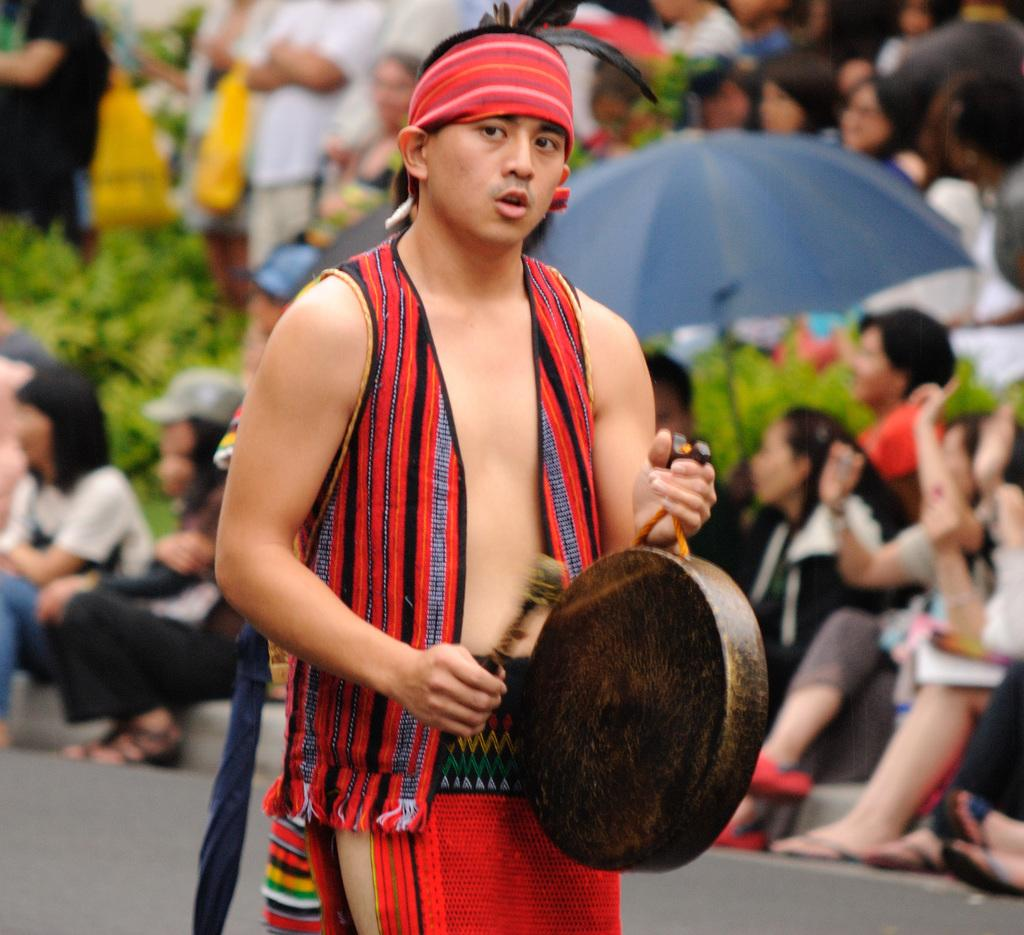What is the man in the image doing? The man is playing a drum. Are there any other people in the image besides the man? Yes, there are people behind the man. What type of vegetation can be seen in the image? There are plants in the image. What object is present to provide shade or protection from the elements? There is an umbrella in the image. Can you describe the process of the frog jumping in the image? There is no frog present in the image, so it is not possible to describe any jumping process. 